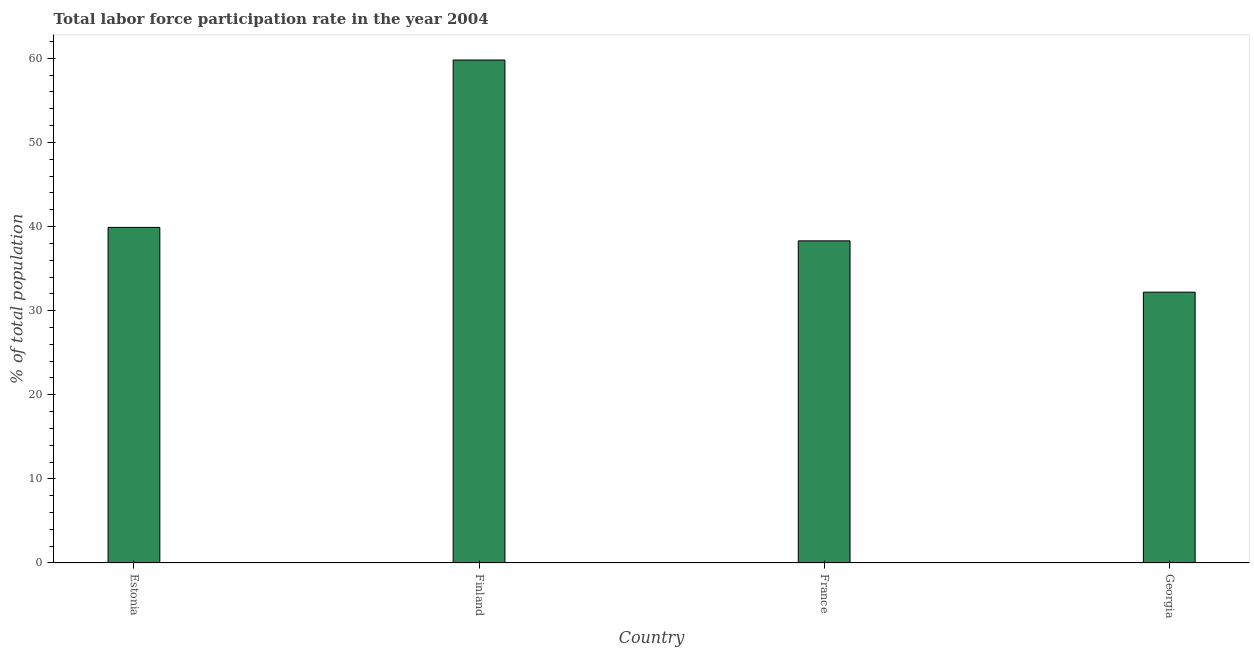Does the graph contain any zero values?
Offer a terse response. No. What is the title of the graph?
Keep it short and to the point. Total labor force participation rate in the year 2004. What is the label or title of the Y-axis?
Offer a very short reply. % of total population. What is the total labor force participation rate in France?
Make the answer very short. 38.3. Across all countries, what is the maximum total labor force participation rate?
Offer a terse response. 59.8. Across all countries, what is the minimum total labor force participation rate?
Give a very brief answer. 32.2. In which country was the total labor force participation rate maximum?
Offer a very short reply. Finland. In which country was the total labor force participation rate minimum?
Provide a succinct answer. Georgia. What is the sum of the total labor force participation rate?
Ensure brevity in your answer.  170.2. What is the difference between the total labor force participation rate in Estonia and Finland?
Your response must be concise. -19.9. What is the average total labor force participation rate per country?
Your answer should be compact. 42.55. What is the median total labor force participation rate?
Offer a very short reply. 39.1. In how many countries, is the total labor force participation rate greater than 2 %?
Give a very brief answer. 4. What is the ratio of the total labor force participation rate in Finland to that in Georgia?
Keep it short and to the point. 1.86. Is the difference between the total labor force participation rate in Finland and France greater than the difference between any two countries?
Give a very brief answer. No. What is the difference between the highest and the second highest total labor force participation rate?
Provide a succinct answer. 19.9. What is the difference between the highest and the lowest total labor force participation rate?
Your response must be concise. 27.6. In how many countries, is the total labor force participation rate greater than the average total labor force participation rate taken over all countries?
Ensure brevity in your answer.  1. How many bars are there?
Offer a terse response. 4. Are all the bars in the graph horizontal?
Your response must be concise. No. What is the difference between two consecutive major ticks on the Y-axis?
Offer a very short reply. 10. Are the values on the major ticks of Y-axis written in scientific E-notation?
Offer a terse response. No. What is the % of total population of Estonia?
Your answer should be compact. 39.9. What is the % of total population in Finland?
Make the answer very short. 59.8. What is the % of total population in France?
Ensure brevity in your answer.  38.3. What is the % of total population in Georgia?
Your answer should be very brief. 32.2. What is the difference between the % of total population in Estonia and Finland?
Your answer should be very brief. -19.9. What is the difference between the % of total population in Estonia and Georgia?
Your answer should be very brief. 7.7. What is the difference between the % of total population in Finland and France?
Your answer should be compact. 21.5. What is the difference between the % of total population in Finland and Georgia?
Give a very brief answer. 27.6. What is the ratio of the % of total population in Estonia to that in Finland?
Ensure brevity in your answer.  0.67. What is the ratio of the % of total population in Estonia to that in France?
Your answer should be compact. 1.04. What is the ratio of the % of total population in Estonia to that in Georgia?
Provide a short and direct response. 1.24. What is the ratio of the % of total population in Finland to that in France?
Offer a very short reply. 1.56. What is the ratio of the % of total population in Finland to that in Georgia?
Make the answer very short. 1.86. What is the ratio of the % of total population in France to that in Georgia?
Provide a short and direct response. 1.19. 